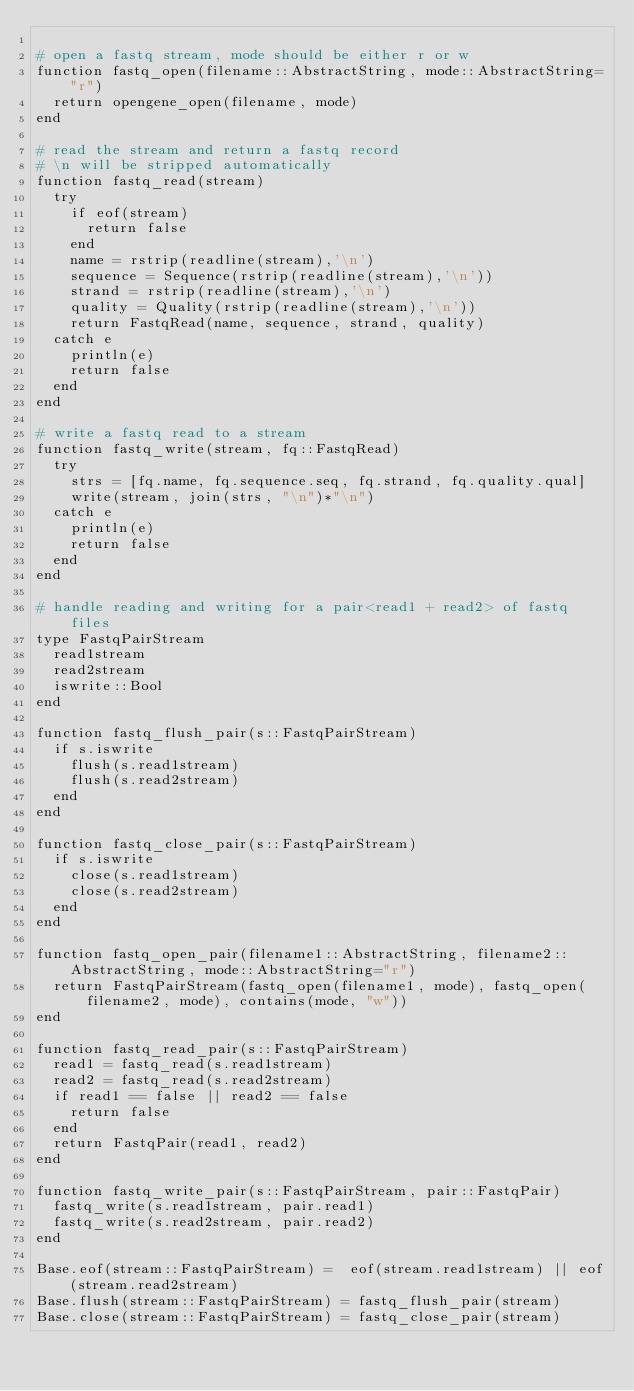Convert code to text. <code><loc_0><loc_0><loc_500><loc_500><_Julia_>
# open a fastq stream, mode should be either r or w
function fastq_open(filename::AbstractString, mode::AbstractString="r")
	return opengene_open(filename, mode)
end

# read the stream and return a fastq record
# \n will be stripped automatically
function fastq_read(stream)
	try
		if eof(stream)
			return false
		end
		name = rstrip(readline(stream),'\n')
		sequence = Sequence(rstrip(readline(stream),'\n'))
		strand = rstrip(readline(stream),'\n')
		quality = Quality(rstrip(readline(stream),'\n'))
		return FastqRead(name, sequence, strand, quality)
	catch e
		println(e)
		return false
	end
end

# write a fastq read to a stream
function fastq_write(stream, fq::FastqRead)
	try
		strs = [fq.name, fq.sequence.seq, fq.strand, fq.quality.qual]
		write(stream, join(strs, "\n")*"\n")
	catch e
		println(e)
		return false
	end
end

# handle reading and writing for a pair<read1 + read2> of fastq files
type FastqPairStream
	read1stream
	read2stream
	iswrite::Bool
end

function fastq_flush_pair(s::FastqPairStream)
	if s.iswrite
		flush(s.read1stream)
		flush(s.read2stream)
	end
end

function fastq_close_pair(s::FastqPairStream)
	if s.iswrite
		close(s.read1stream)
		close(s.read2stream)
	end
end

function fastq_open_pair(filename1::AbstractString, filename2::AbstractString, mode::AbstractString="r")
	return FastqPairStream(fastq_open(filename1, mode), fastq_open(filename2, mode), contains(mode, "w"))
end

function fastq_read_pair(s::FastqPairStream)
	read1 = fastq_read(s.read1stream)
	read2 = fastq_read(s.read2stream)
	if read1 == false || read2 == false
		return false
	end
	return FastqPair(read1, read2)
end

function fastq_write_pair(s::FastqPairStream, pair::FastqPair)
	fastq_write(s.read1stream, pair.read1)
	fastq_write(s.read2stream, pair.read2)
end

Base.eof(stream::FastqPairStream) =  eof(stream.read1stream) || eof(stream.read2stream)
Base.flush(stream::FastqPairStream) = fastq_flush_pair(stream)
Base.close(stream::FastqPairStream) = fastq_close_pair(stream)
</code> 